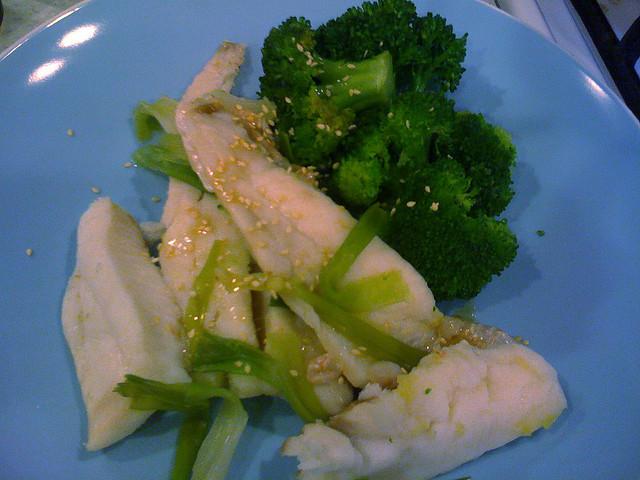What is the main entree?
Write a very short answer. Fish. Are there sesame seeds in this dish?
Short answer required. Yes. What is the dark green vegetable?
Short answer required. Broccoli. Are there tomatoes on this food?
Keep it brief. No. How many slices of meat are on the plate?
Short answer required. 5. Is there a red food on the plate?
Write a very short answer. No. Would a vegetarian eat this?
Concise answer only. Yes. What color is the plate?
Write a very short answer. Blue. Is the broccoli raw?
Answer briefly. No. Is the spoon sterling silver?
Keep it brief. No. Is this a vegan meal?
Write a very short answer. No. Is there broccoli in the kitchen?
Quick response, please. Yes. How many different kinds of foods are here?
Write a very short answer. 2. What vegetable do you see?
Give a very brief answer. Broccoli. Is this edible?
Concise answer only. Yes. What is on top of the broccoli?
Write a very short answer. Sesame seeds. What type of meat is behind the veggies?
Quick response, please. Fish. What is green?
Short answer required. Broccoli. Is tea available?
Short answer required. No. 